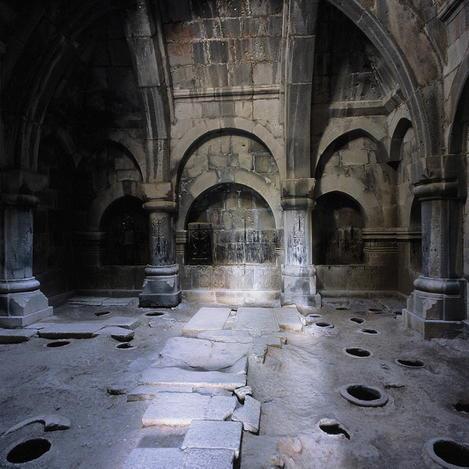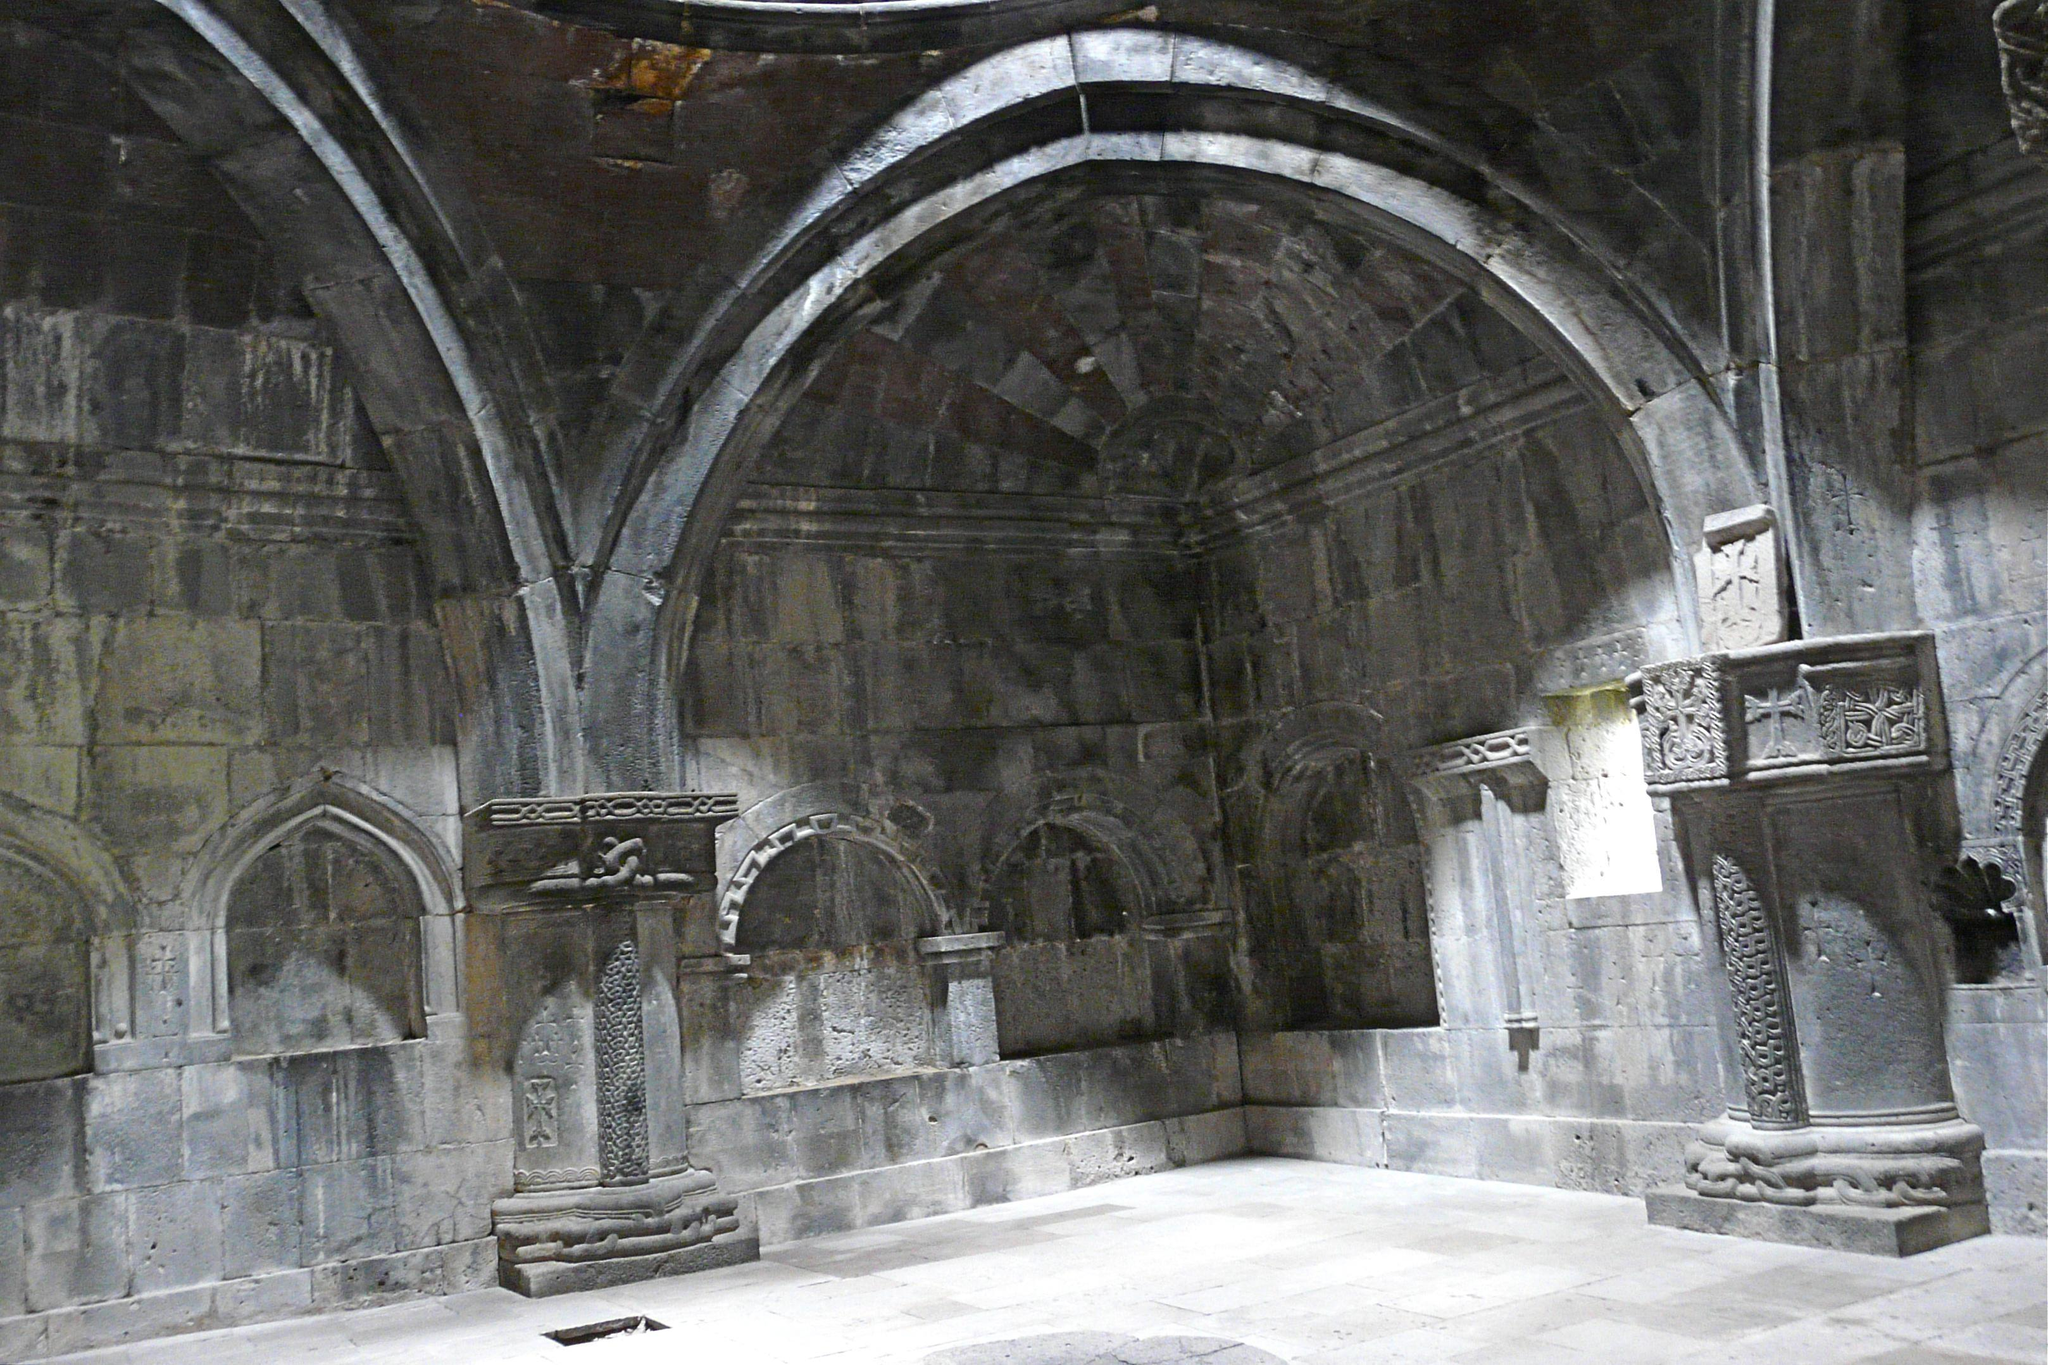The first image is the image on the left, the second image is the image on the right. Analyze the images presented: Is the assertion "A grassy outdoor area can be seen near the building in the image on the left." valid? Answer yes or no. No. The first image is the image on the left, the second image is the image on the right. Analyze the images presented: Is the assertion "An image shows green lawn and a view of the outdoors through an archway." valid? Answer yes or no. No. 